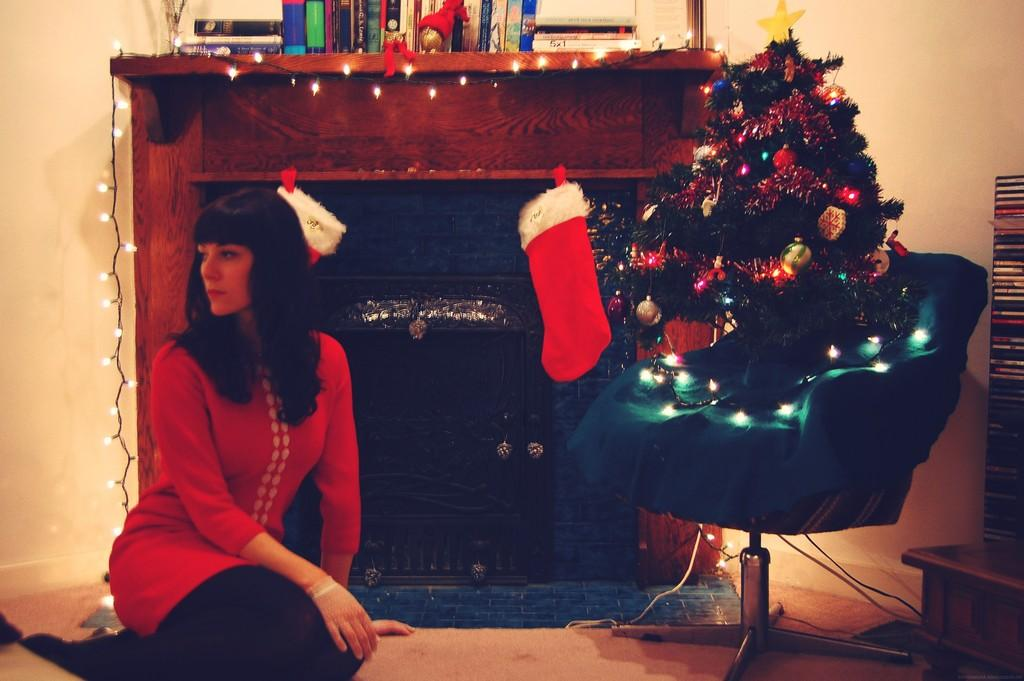What is the person in the image doing? There is a person sitting in the image. What is placed on the chair in the image? There is a Christmas tree on a chair in the image. What can be seen at the top of the image? There are books visible at the top of the image. What is the person arguing about with the air in the image? There is no person arguing with the air in the image, nor is there any indication of an argument. 